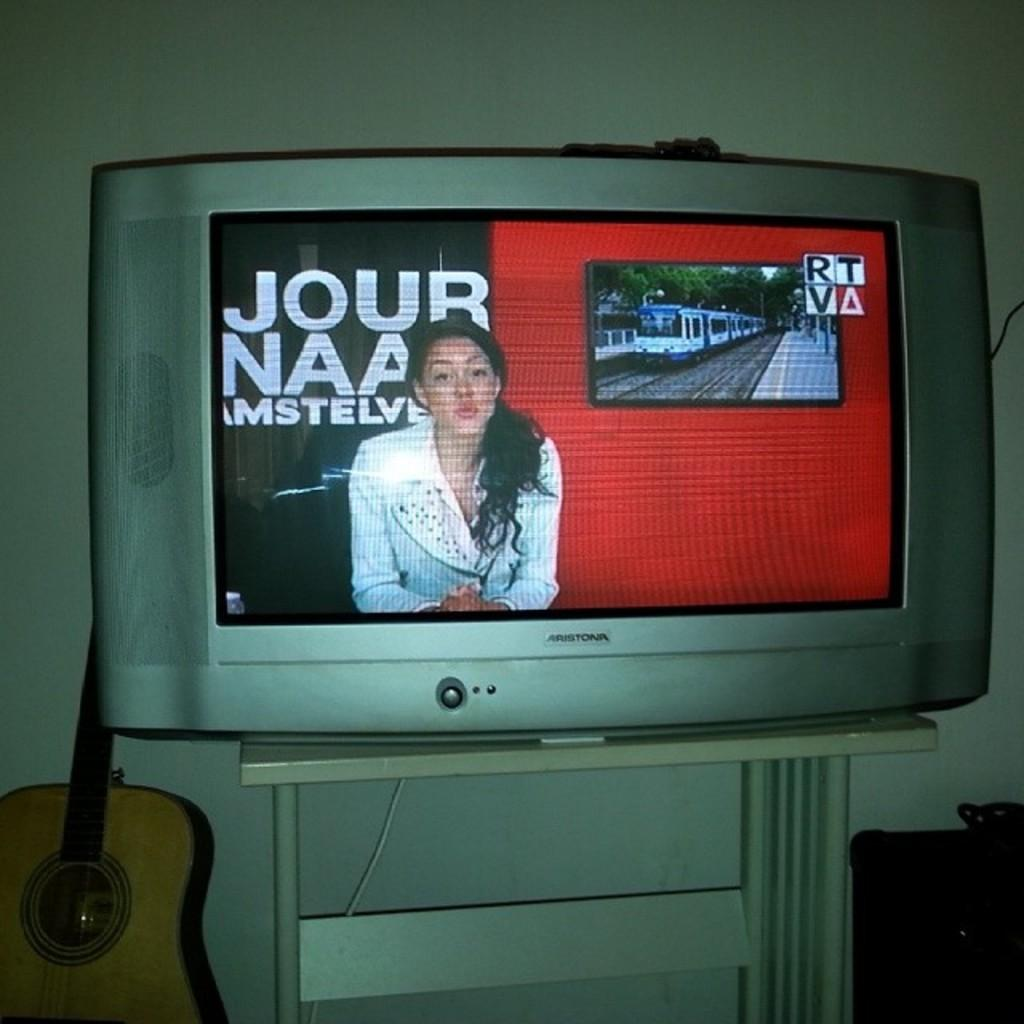<image>
Relay a brief, clear account of the picture shown. The Aristonia branded TV shows a news program. 